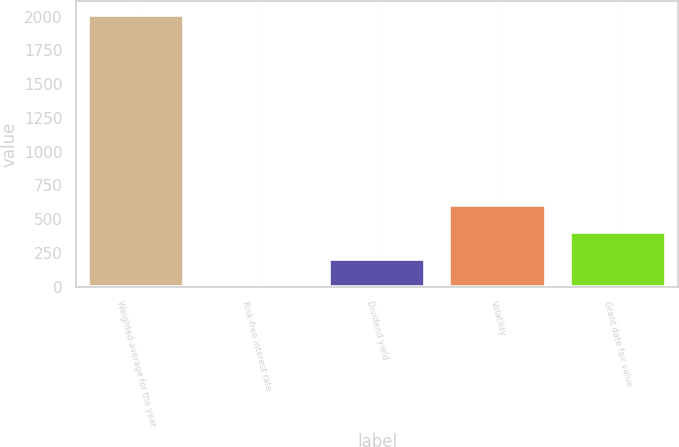Convert chart. <chart><loc_0><loc_0><loc_500><loc_500><bar_chart><fcel>Weighted-average for the year<fcel>Risk-free interest rate<fcel>Dividend yield<fcel>Volatility<fcel>Grant date fair value<nl><fcel>2012<fcel>1.1<fcel>202.19<fcel>604.37<fcel>403.28<nl></chart> 